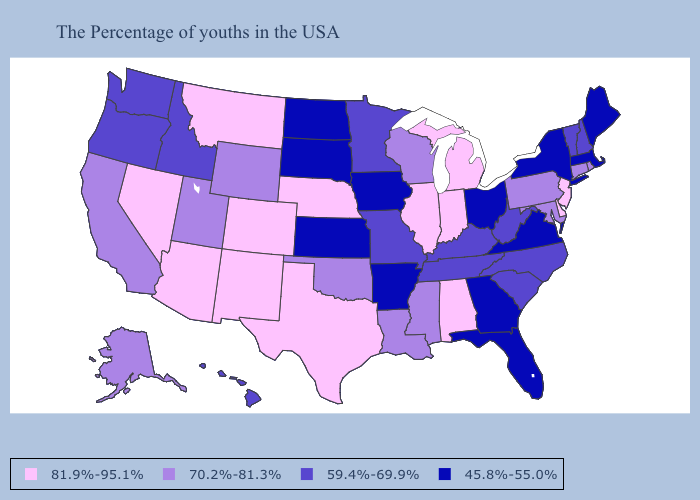Among the states that border Indiana , which have the highest value?
Write a very short answer. Michigan, Illinois. What is the highest value in states that border Colorado?
Short answer required. 81.9%-95.1%. Among the states that border Montana , does North Dakota have the highest value?
Answer briefly. No. Does the map have missing data?
Short answer required. No. Among the states that border Montana , does Idaho have the lowest value?
Answer briefly. No. Name the states that have a value in the range 59.4%-69.9%?
Quick response, please. New Hampshire, Vermont, North Carolina, South Carolina, West Virginia, Kentucky, Tennessee, Missouri, Minnesota, Idaho, Washington, Oregon, Hawaii. What is the lowest value in states that border Nebraska?
Be succinct. 45.8%-55.0%. Does Kansas have the lowest value in the USA?
Short answer required. Yes. Does Maine have the lowest value in the Northeast?
Give a very brief answer. Yes. Does Indiana have the highest value in the USA?
Write a very short answer. Yes. What is the value of Washington?
Concise answer only. 59.4%-69.9%. What is the value of Virginia?
Quick response, please. 45.8%-55.0%. Does Maine have a lower value than South Dakota?
Concise answer only. No. What is the lowest value in states that border Nebraska?
Answer briefly. 45.8%-55.0%. Among the states that border Utah , which have the highest value?
Quick response, please. Colorado, New Mexico, Arizona, Nevada. 